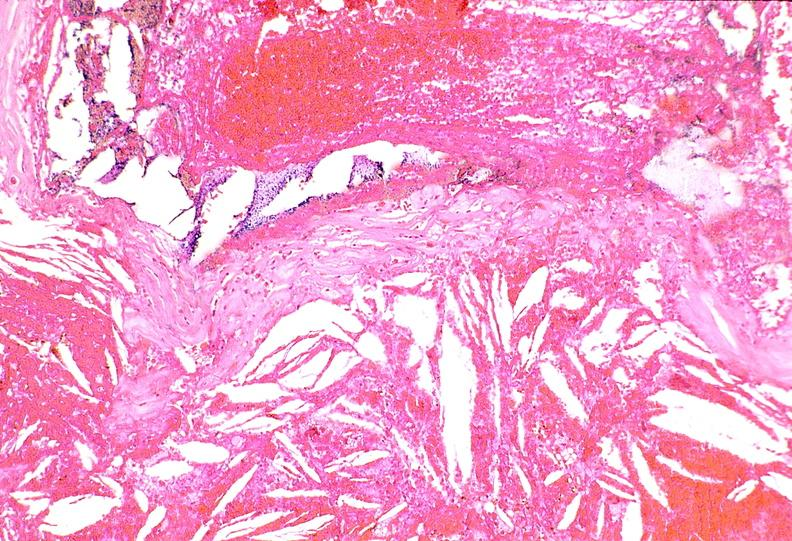what is present?
Answer the question using a single word or phrase. Vasculature 